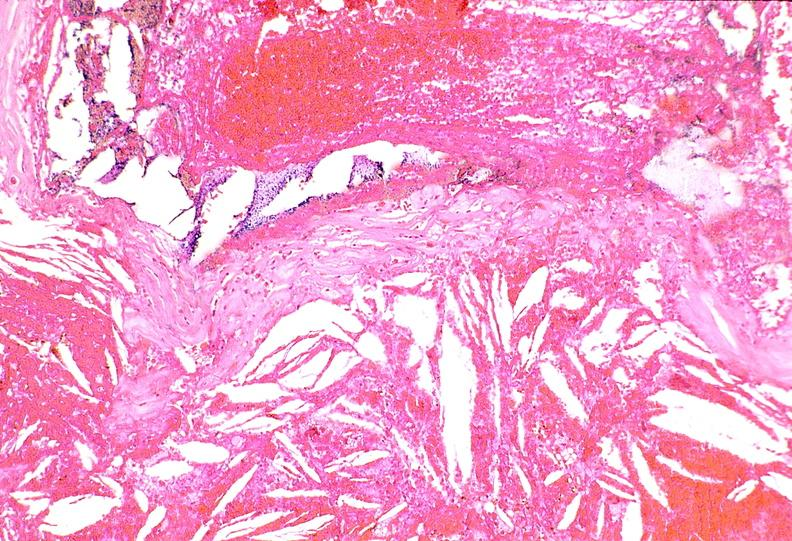what is present?
Answer the question using a single word or phrase. Vasculature 